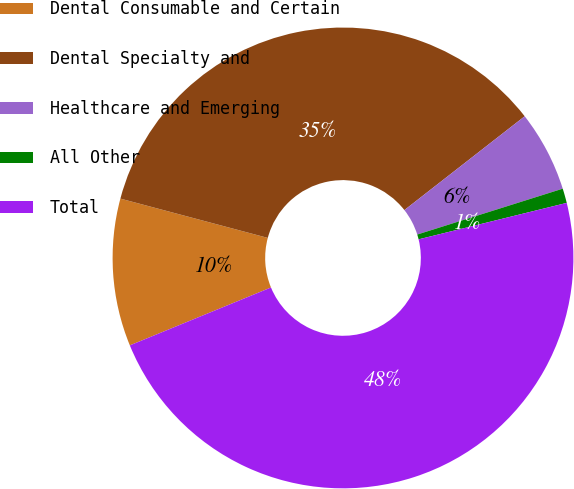<chart> <loc_0><loc_0><loc_500><loc_500><pie_chart><fcel>Dental Consumable and Certain<fcel>Dental Specialty and<fcel>Healthcare and Emerging<fcel>All Other<fcel>Total<nl><fcel>10.34%<fcel>35.31%<fcel>5.68%<fcel>1.02%<fcel>47.64%<nl></chart> 